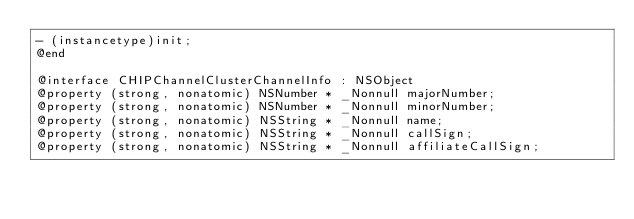Convert code to text. <code><loc_0><loc_0><loc_500><loc_500><_C_>- (instancetype)init;
@end

@interface CHIPChannelClusterChannelInfo : NSObject
@property (strong, nonatomic) NSNumber * _Nonnull majorNumber;
@property (strong, nonatomic) NSNumber * _Nonnull minorNumber;
@property (strong, nonatomic) NSString * _Nonnull name;
@property (strong, nonatomic) NSString * _Nonnull callSign;
@property (strong, nonatomic) NSString * _Nonnull affiliateCallSign;</code> 